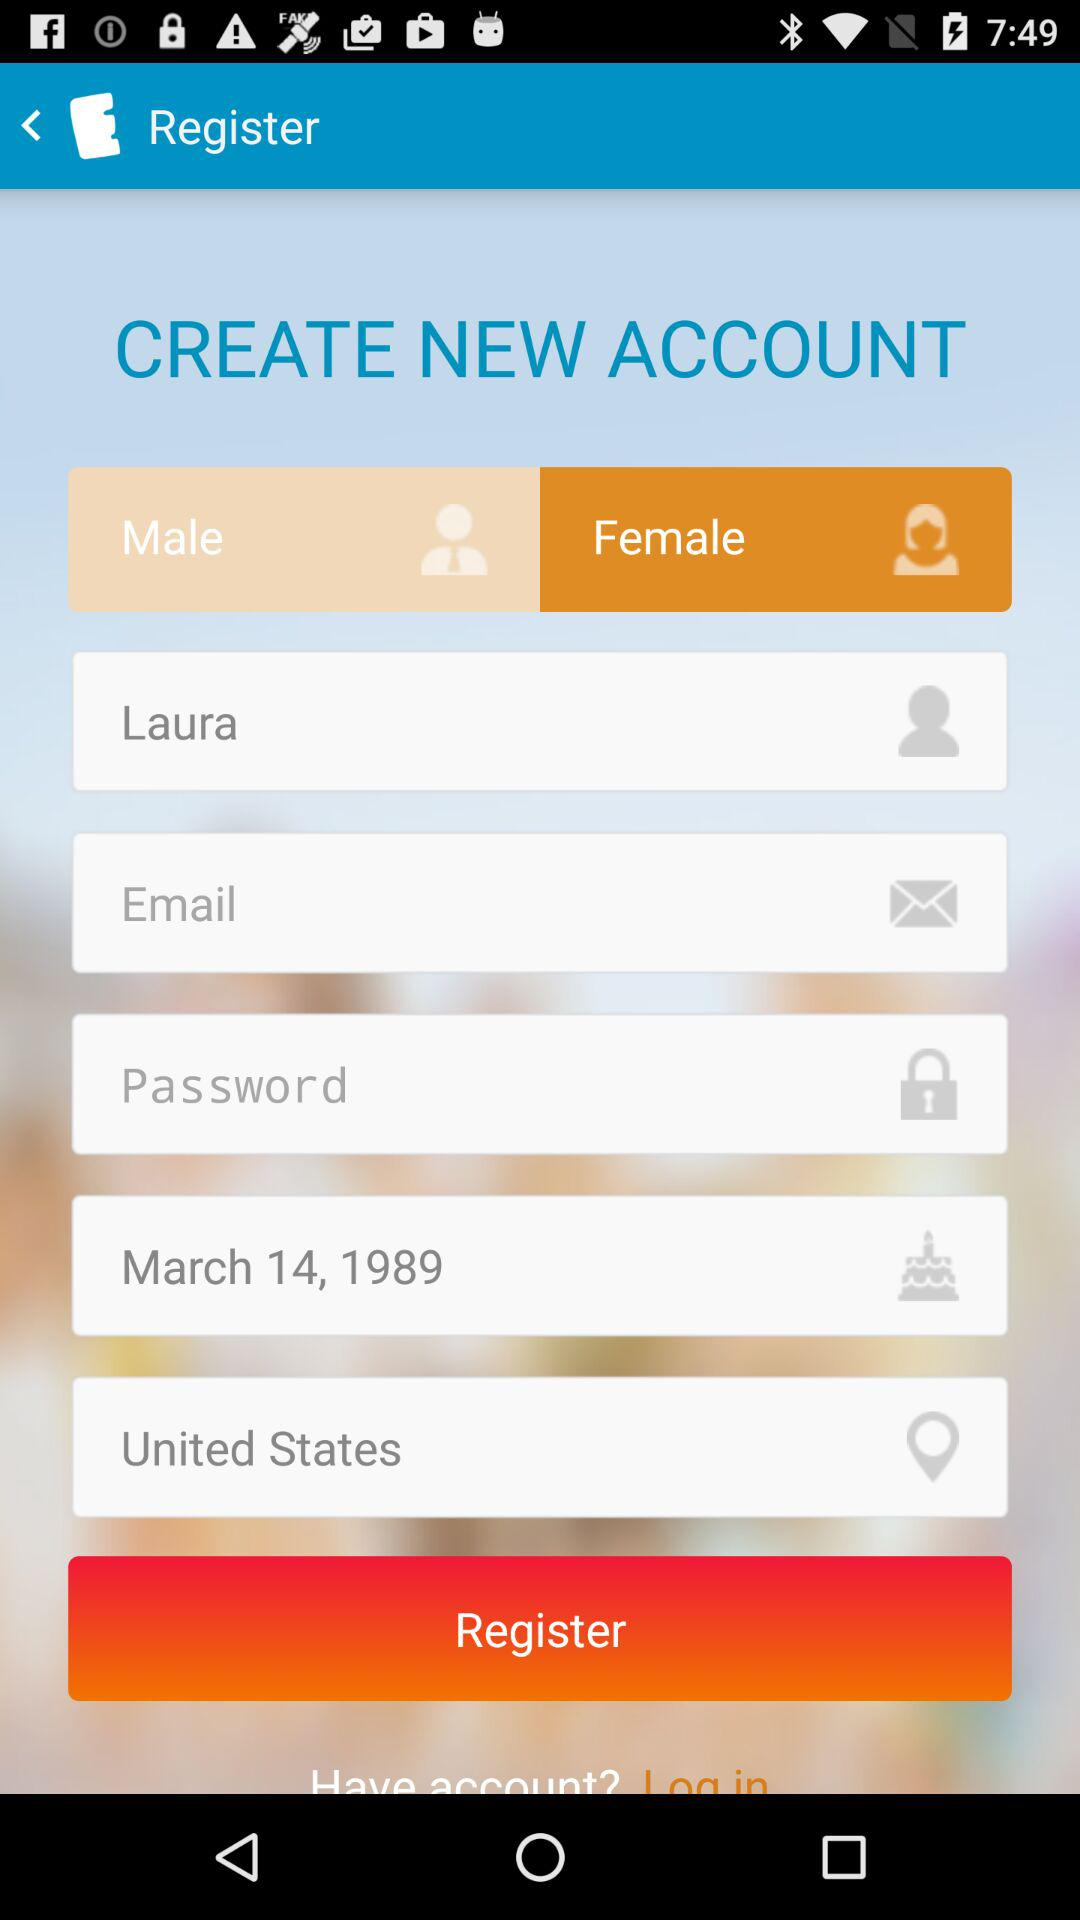How many input fields are required to register for an account?
Answer the question using a single word or phrase. 6 